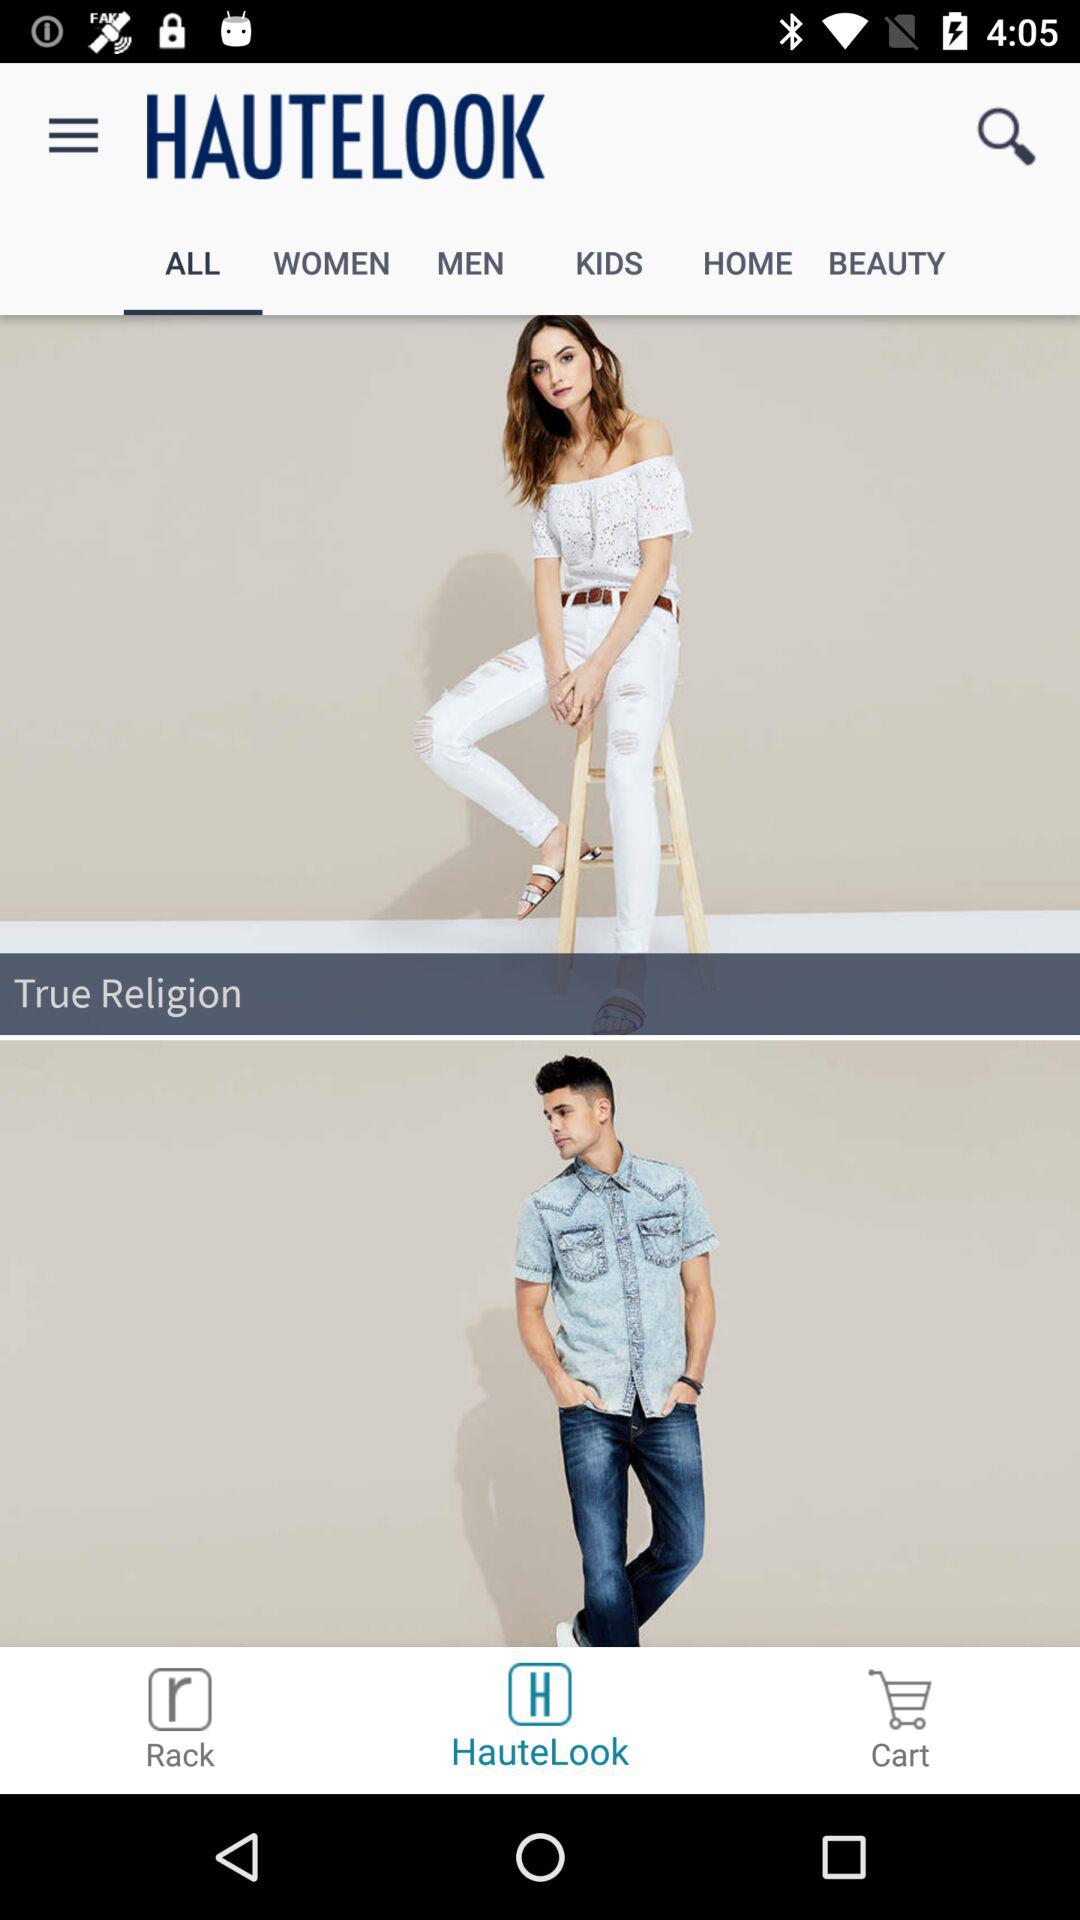Which tab is selected? The selected tabs are "ALL" and "HauteLook". 